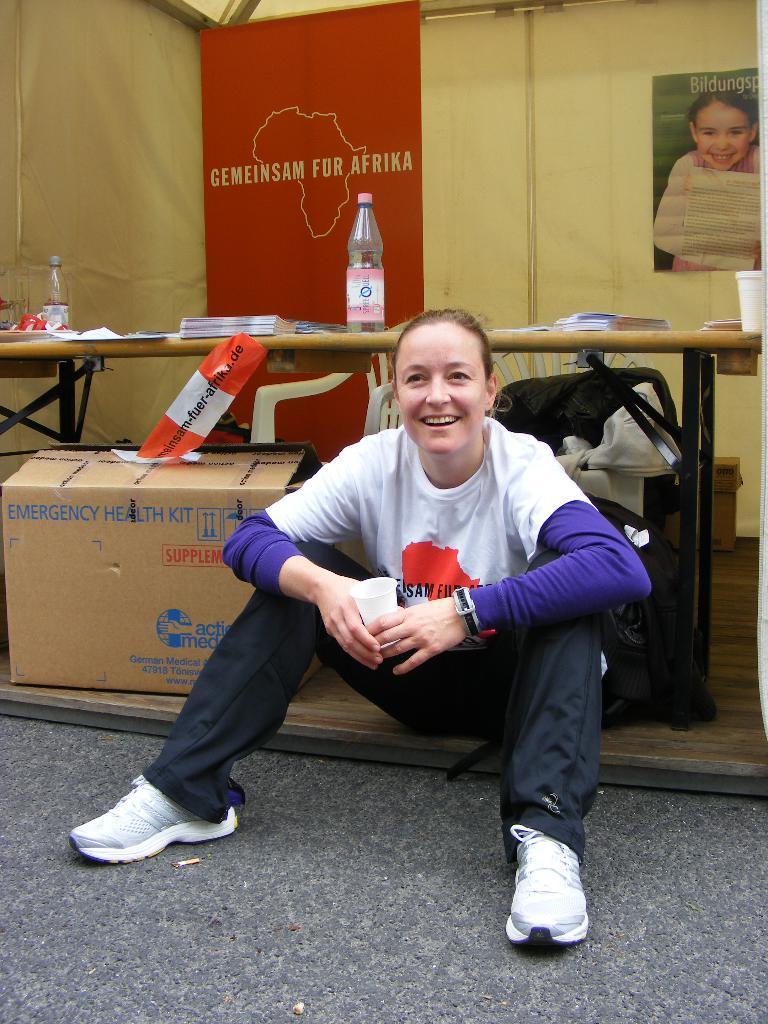Describe this image in one or two sentences. Here we can see a lady sitting on ground with a cup in her hand laughing and behind her we can see table with bottles on it and beside her we can see a box and on the wall behind her we can see a photo of a baby 